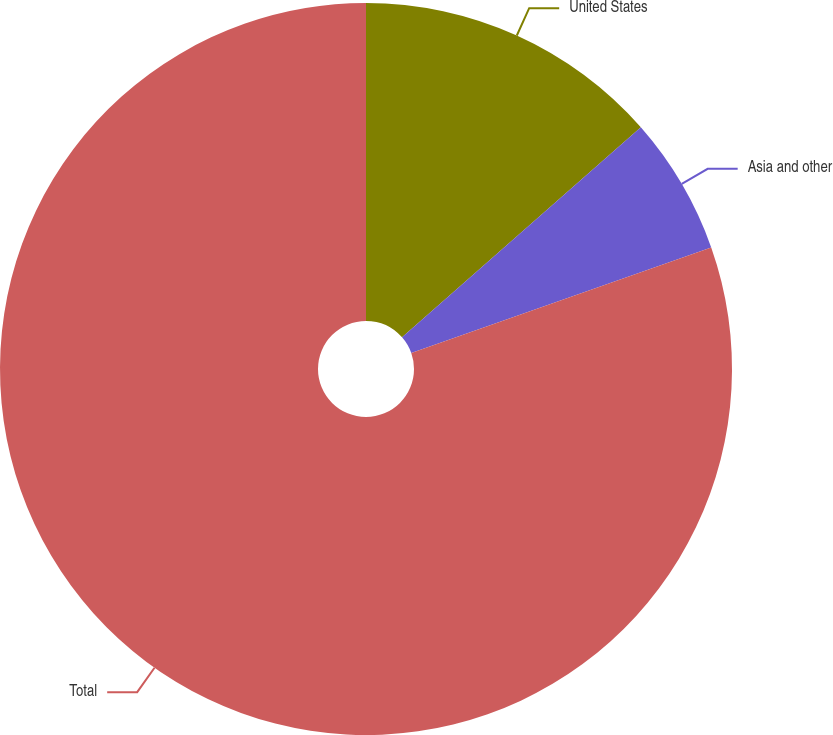<chart> <loc_0><loc_0><loc_500><loc_500><pie_chart><fcel>United States<fcel>Asia and other<fcel>Total<nl><fcel>13.52%<fcel>6.09%<fcel>80.39%<nl></chart> 